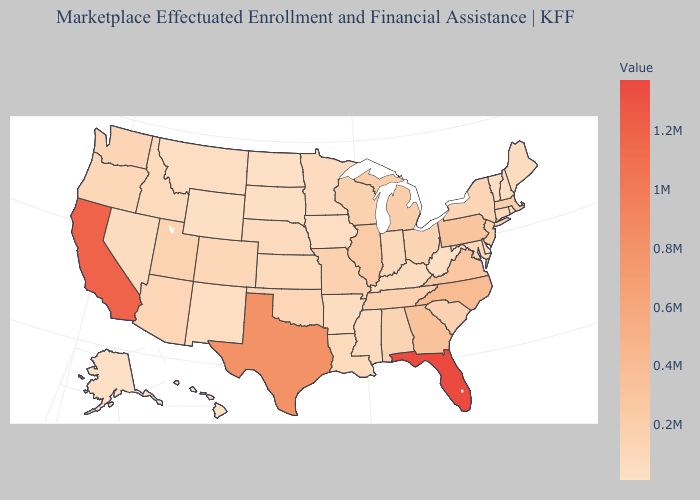Among the states that border Vermont , does Massachusetts have the highest value?
Give a very brief answer. Yes. Among the states that border Oregon , which have the lowest value?
Write a very short answer. Nevada. Among the states that border Nebraska , which have the highest value?
Write a very short answer. Missouri. Does Florida have the highest value in the USA?
Give a very brief answer. Yes. Which states have the highest value in the USA?
Concise answer only. Florida. 